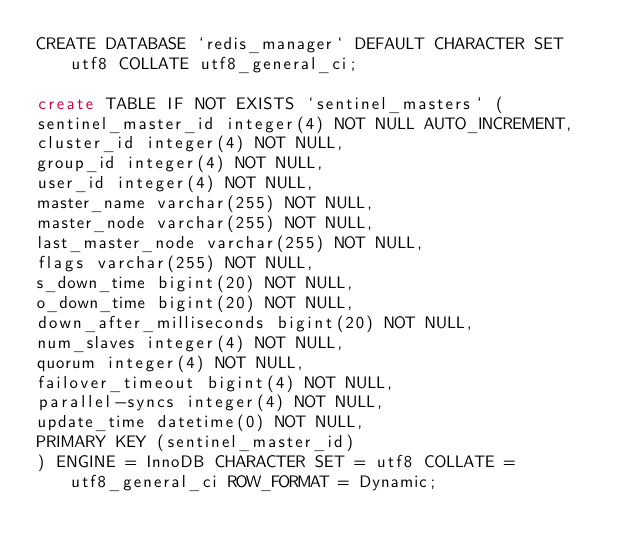Convert code to text. <code><loc_0><loc_0><loc_500><loc_500><_SQL_>CREATE DATABASE `redis_manager` DEFAULT CHARACTER SET utf8 COLLATE utf8_general_ci;

create TABLE IF NOT EXISTS `sentinel_masters` (
sentinel_master_id integer(4) NOT NULL AUTO_INCREMENT,
cluster_id integer(4) NOT NULL,
group_id integer(4) NOT NULL,
user_id integer(4) NOT NULL,
master_name varchar(255) NOT NULL,
master_node varchar(255) NOT NULL,
last_master_node varchar(255) NOT NULL,
flags varchar(255) NOT NULL,
s_down_time bigint(20) NOT NULL,
o_down_time bigint(20) NOT NULL,
down_after_milliseconds bigint(20) NOT NULL,
num_slaves integer(4) NOT NULL,
quorum integer(4) NOT NULL,
failover_timeout bigint(4) NOT NULL,
parallel-syncs integer(4) NOT NULL,
update_time datetime(0) NOT NULL,
PRIMARY KEY (sentinel_master_id)
) ENGINE = InnoDB CHARACTER SET = utf8 COLLATE = utf8_general_ci ROW_FORMAT = Dynamic;</code> 